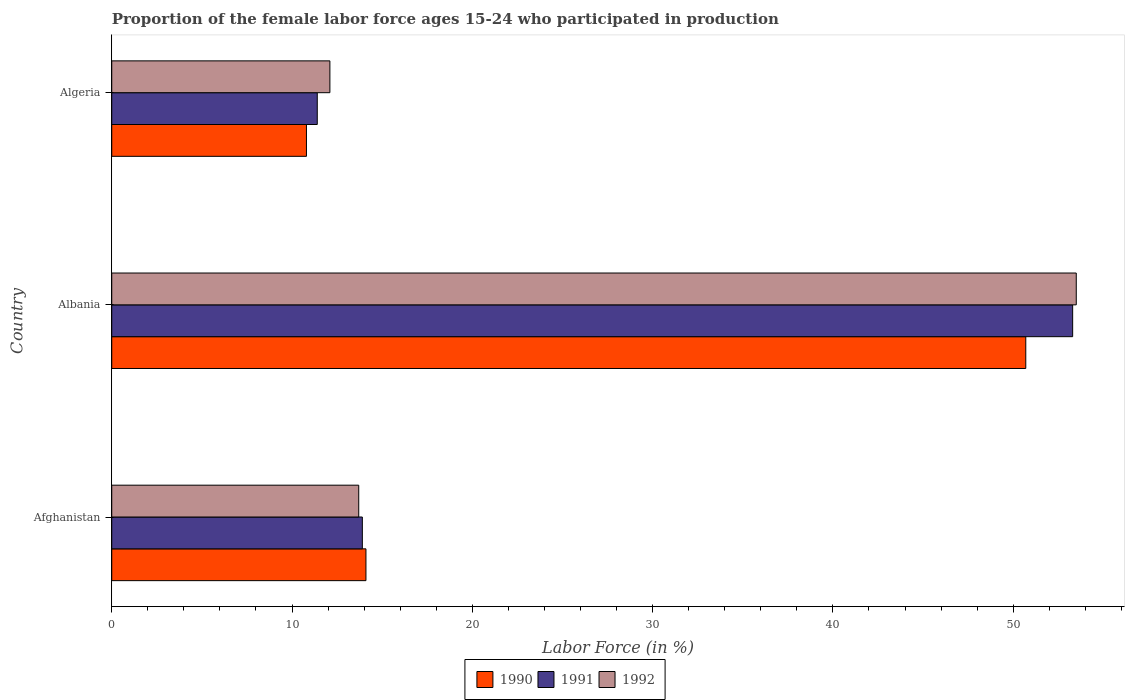How many different coloured bars are there?
Offer a terse response. 3. How many groups of bars are there?
Keep it short and to the point. 3. Are the number of bars on each tick of the Y-axis equal?
Give a very brief answer. Yes. What is the label of the 2nd group of bars from the top?
Your answer should be compact. Albania. What is the proportion of the female labor force who participated in production in 1992 in Algeria?
Keep it short and to the point. 12.1. Across all countries, what is the maximum proportion of the female labor force who participated in production in 1990?
Provide a short and direct response. 50.7. Across all countries, what is the minimum proportion of the female labor force who participated in production in 1991?
Provide a short and direct response. 11.4. In which country was the proportion of the female labor force who participated in production in 1991 maximum?
Make the answer very short. Albania. In which country was the proportion of the female labor force who participated in production in 1991 minimum?
Your response must be concise. Algeria. What is the total proportion of the female labor force who participated in production in 1992 in the graph?
Make the answer very short. 79.3. What is the difference between the proportion of the female labor force who participated in production in 1990 in Albania and that in Algeria?
Your answer should be compact. 39.9. What is the difference between the proportion of the female labor force who participated in production in 1991 in Algeria and the proportion of the female labor force who participated in production in 1992 in Afghanistan?
Make the answer very short. -2.3. What is the average proportion of the female labor force who participated in production in 1990 per country?
Ensure brevity in your answer.  25.2. What is the difference between the proportion of the female labor force who participated in production in 1990 and proportion of the female labor force who participated in production in 1991 in Afghanistan?
Offer a terse response. 0.2. In how many countries, is the proportion of the female labor force who participated in production in 1990 greater than 50 %?
Keep it short and to the point. 1. What is the ratio of the proportion of the female labor force who participated in production in 1991 in Afghanistan to that in Albania?
Provide a short and direct response. 0.26. Is the difference between the proportion of the female labor force who participated in production in 1990 in Afghanistan and Albania greater than the difference between the proportion of the female labor force who participated in production in 1991 in Afghanistan and Albania?
Ensure brevity in your answer.  Yes. What is the difference between the highest and the second highest proportion of the female labor force who participated in production in 1990?
Your response must be concise. 36.6. What is the difference between the highest and the lowest proportion of the female labor force who participated in production in 1990?
Provide a succinct answer. 39.9. What does the 1st bar from the top in Albania represents?
Offer a very short reply. 1992. Is it the case that in every country, the sum of the proportion of the female labor force who participated in production in 1991 and proportion of the female labor force who participated in production in 1990 is greater than the proportion of the female labor force who participated in production in 1992?
Provide a succinct answer. Yes. Are all the bars in the graph horizontal?
Your answer should be very brief. Yes. How many countries are there in the graph?
Provide a succinct answer. 3. What is the difference between two consecutive major ticks on the X-axis?
Give a very brief answer. 10. Are the values on the major ticks of X-axis written in scientific E-notation?
Your answer should be compact. No. Does the graph contain any zero values?
Provide a short and direct response. No. Where does the legend appear in the graph?
Keep it short and to the point. Bottom center. How many legend labels are there?
Offer a terse response. 3. How are the legend labels stacked?
Offer a very short reply. Horizontal. What is the title of the graph?
Offer a terse response. Proportion of the female labor force ages 15-24 who participated in production. What is the label or title of the X-axis?
Ensure brevity in your answer.  Labor Force (in %). What is the Labor Force (in %) in 1990 in Afghanistan?
Your answer should be compact. 14.1. What is the Labor Force (in %) in 1991 in Afghanistan?
Keep it short and to the point. 13.9. What is the Labor Force (in %) in 1992 in Afghanistan?
Ensure brevity in your answer.  13.7. What is the Labor Force (in %) of 1990 in Albania?
Make the answer very short. 50.7. What is the Labor Force (in %) in 1991 in Albania?
Give a very brief answer. 53.3. What is the Labor Force (in %) of 1992 in Albania?
Offer a terse response. 53.5. What is the Labor Force (in %) of 1990 in Algeria?
Your response must be concise. 10.8. What is the Labor Force (in %) of 1991 in Algeria?
Make the answer very short. 11.4. What is the Labor Force (in %) of 1992 in Algeria?
Your response must be concise. 12.1. Across all countries, what is the maximum Labor Force (in %) in 1990?
Keep it short and to the point. 50.7. Across all countries, what is the maximum Labor Force (in %) in 1991?
Keep it short and to the point. 53.3. Across all countries, what is the maximum Labor Force (in %) of 1992?
Make the answer very short. 53.5. Across all countries, what is the minimum Labor Force (in %) of 1990?
Provide a succinct answer. 10.8. Across all countries, what is the minimum Labor Force (in %) in 1991?
Your answer should be very brief. 11.4. Across all countries, what is the minimum Labor Force (in %) in 1992?
Your response must be concise. 12.1. What is the total Labor Force (in %) in 1990 in the graph?
Provide a succinct answer. 75.6. What is the total Labor Force (in %) in 1991 in the graph?
Your answer should be compact. 78.6. What is the total Labor Force (in %) of 1992 in the graph?
Make the answer very short. 79.3. What is the difference between the Labor Force (in %) in 1990 in Afghanistan and that in Albania?
Your response must be concise. -36.6. What is the difference between the Labor Force (in %) of 1991 in Afghanistan and that in Albania?
Offer a very short reply. -39.4. What is the difference between the Labor Force (in %) in 1992 in Afghanistan and that in Albania?
Make the answer very short. -39.8. What is the difference between the Labor Force (in %) in 1992 in Afghanistan and that in Algeria?
Your response must be concise. 1.6. What is the difference between the Labor Force (in %) of 1990 in Albania and that in Algeria?
Your response must be concise. 39.9. What is the difference between the Labor Force (in %) in 1991 in Albania and that in Algeria?
Make the answer very short. 41.9. What is the difference between the Labor Force (in %) in 1992 in Albania and that in Algeria?
Ensure brevity in your answer.  41.4. What is the difference between the Labor Force (in %) in 1990 in Afghanistan and the Labor Force (in %) in 1991 in Albania?
Provide a succinct answer. -39.2. What is the difference between the Labor Force (in %) in 1990 in Afghanistan and the Labor Force (in %) in 1992 in Albania?
Ensure brevity in your answer.  -39.4. What is the difference between the Labor Force (in %) in 1991 in Afghanistan and the Labor Force (in %) in 1992 in Albania?
Make the answer very short. -39.6. What is the difference between the Labor Force (in %) in 1990 in Afghanistan and the Labor Force (in %) in 1991 in Algeria?
Your answer should be very brief. 2.7. What is the difference between the Labor Force (in %) in 1990 in Albania and the Labor Force (in %) in 1991 in Algeria?
Provide a succinct answer. 39.3. What is the difference between the Labor Force (in %) in 1990 in Albania and the Labor Force (in %) in 1992 in Algeria?
Provide a short and direct response. 38.6. What is the difference between the Labor Force (in %) in 1991 in Albania and the Labor Force (in %) in 1992 in Algeria?
Provide a succinct answer. 41.2. What is the average Labor Force (in %) of 1990 per country?
Your answer should be very brief. 25.2. What is the average Labor Force (in %) of 1991 per country?
Your answer should be very brief. 26.2. What is the average Labor Force (in %) in 1992 per country?
Ensure brevity in your answer.  26.43. What is the difference between the Labor Force (in %) of 1990 and Labor Force (in %) of 1992 in Afghanistan?
Provide a short and direct response. 0.4. What is the difference between the Labor Force (in %) in 1991 and Labor Force (in %) in 1992 in Afghanistan?
Keep it short and to the point. 0.2. What is the difference between the Labor Force (in %) in 1990 and Labor Force (in %) in 1992 in Albania?
Keep it short and to the point. -2.8. What is the difference between the Labor Force (in %) in 1990 and Labor Force (in %) in 1991 in Algeria?
Offer a very short reply. -0.6. What is the difference between the Labor Force (in %) of 1990 and Labor Force (in %) of 1992 in Algeria?
Give a very brief answer. -1.3. What is the ratio of the Labor Force (in %) in 1990 in Afghanistan to that in Albania?
Your answer should be compact. 0.28. What is the ratio of the Labor Force (in %) in 1991 in Afghanistan to that in Albania?
Your response must be concise. 0.26. What is the ratio of the Labor Force (in %) of 1992 in Afghanistan to that in Albania?
Your answer should be compact. 0.26. What is the ratio of the Labor Force (in %) in 1990 in Afghanistan to that in Algeria?
Your response must be concise. 1.31. What is the ratio of the Labor Force (in %) of 1991 in Afghanistan to that in Algeria?
Ensure brevity in your answer.  1.22. What is the ratio of the Labor Force (in %) of 1992 in Afghanistan to that in Algeria?
Give a very brief answer. 1.13. What is the ratio of the Labor Force (in %) in 1990 in Albania to that in Algeria?
Provide a succinct answer. 4.69. What is the ratio of the Labor Force (in %) of 1991 in Albania to that in Algeria?
Offer a terse response. 4.68. What is the ratio of the Labor Force (in %) of 1992 in Albania to that in Algeria?
Provide a short and direct response. 4.42. What is the difference between the highest and the second highest Labor Force (in %) of 1990?
Your response must be concise. 36.6. What is the difference between the highest and the second highest Labor Force (in %) in 1991?
Your answer should be compact. 39.4. What is the difference between the highest and the second highest Labor Force (in %) in 1992?
Your response must be concise. 39.8. What is the difference between the highest and the lowest Labor Force (in %) of 1990?
Offer a terse response. 39.9. What is the difference between the highest and the lowest Labor Force (in %) of 1991?
Your response must be concise. 41.9. What is the difference between the highest and the lowest Labor Force (in %) of 1992?
Your response must be concise. 41.4. 